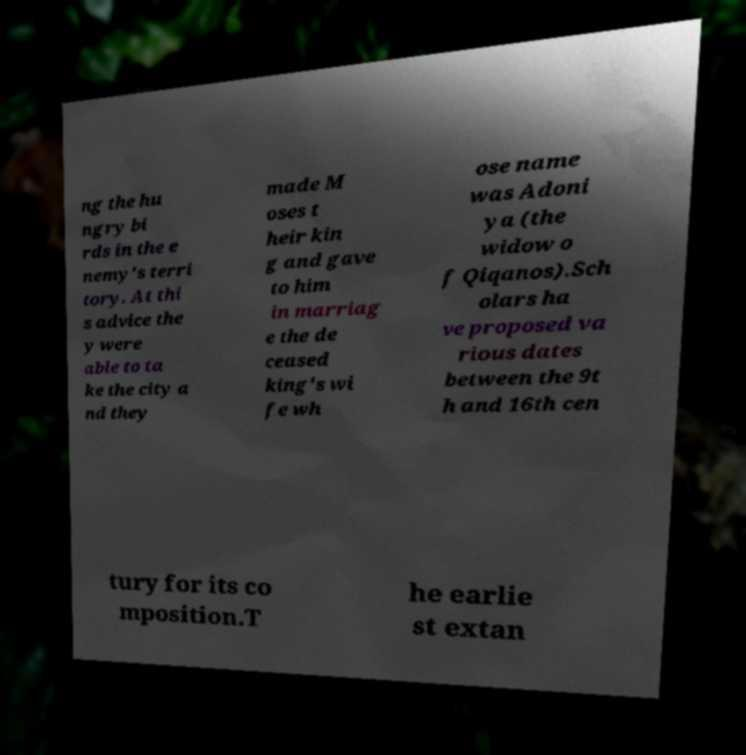Please read and relay the text visible in this image. What does it say? ng the hu ngry bi rds in the e nemy's terri tory. At thi s advice the y were able to ta ke the city a nd they made M oses t heir kin g and gave to him in marriag e the de ceased king's wi fe wh ose name was Adoni ya (the widow o f Qiqanos).Sch olars ha ve proposed va rious dates between the 9t h and 16th cen tury for its co mposition.T he earlie st extan 